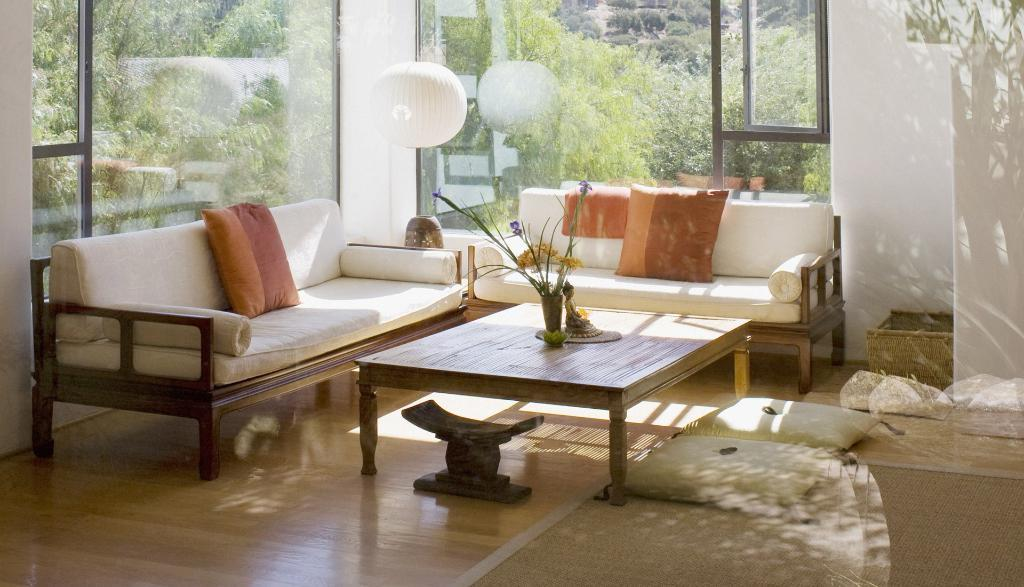What type of furniture is present in the image? There is a couch in the image. What is placed on the table in the image? There is a flower vase on the table in the image. What type of door is visible in the image? There is a glass door in the image. What can be seen in the background of the image? Trees are visible in the background of the image. How many slaves are visible in the image? There are no slaves present in the image. What type of cup is placed next to the flower vase in the image? There is no cup present next to the flower vase in the image. 